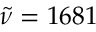Convert formula to latex. <formula><loc_0><loc_0><loc_500><loc_500>\tilde { \nu } = 1 6 8 1</formula> 